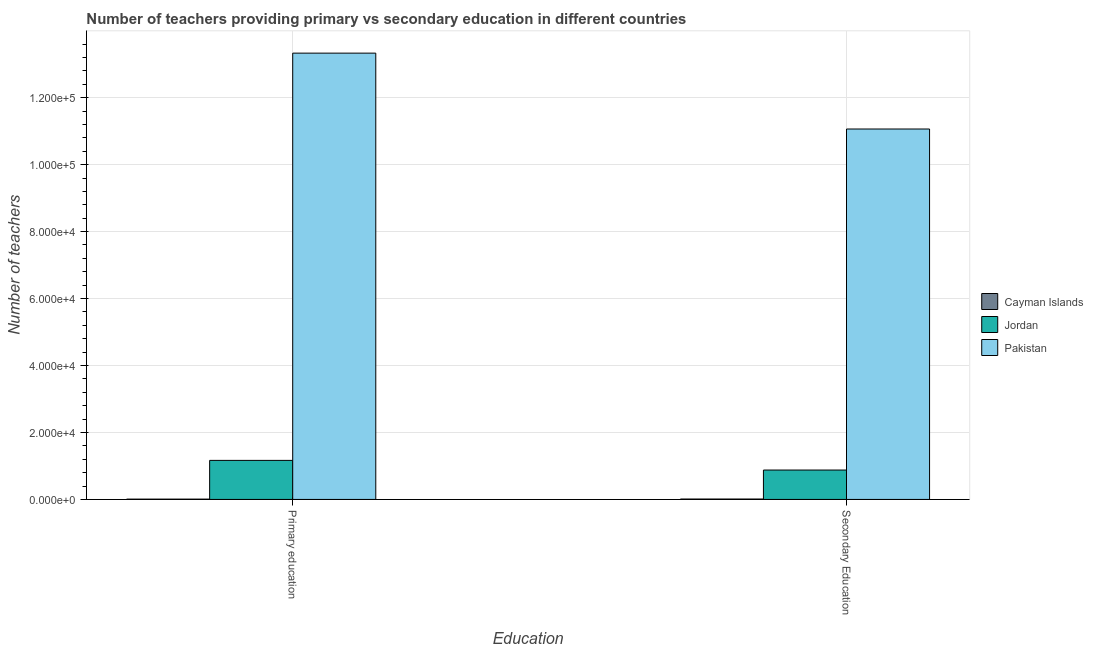How many groups of bars are there?
Your response must be concise. 2. Are the number of bars on each tick of the X-axis equal?
Give a very brief answer. Yes. How many bars are there on the 1st tick from the left?
Provide a short and direct response. 3. How many bars are there on the 1st tick from the right?
Your answer should be compact. 3. What is the number of secondary teachers in Jordan?
Keep it short and to the point. 8779. Across all countries, what is the maximum number of primary teachers?
Make the answer very short. 1.33e+05. Across all countries, what is the minimum number of secondary teachers?
Give a very brief answer. 114. In which country was the number of primary teachers minimum?
Your answer should be very brief. Cayman Islands. What is the total number of primary teachers in the graph?
Keep it short and to the point. 1.45e+05. What is the difference between the number of secondary teachers in Jordan and that in Pakistan?
Offer a very short reply. -1.02e+05. What is the difference between the number of primary teachers in Cayman Islands and the number of secondary teachers in Jordan?
Offer a terse response. -8691. What is the average number of secondary teachers per country?
Your answer should be very brief. 3.98e+04. What is the difference between the number of primary teachers and number of secondary teachers in Jordan?
Offer a very short reply. 2882. What is the ratio of the number of secondary teachers in Pakistan to that in Jordan?
Offer a terse response. 12.6. Is the number of primary teachers in Cayman Islands less than that in Pakistan?
Your answer should be compact. Yes. What does the 2nd bar from the left in Primary education represents?
Your answer should be compact. Jordan. How many bars are there?
Your answer should be compact. 6. Are all the bars in the graph horizontal?
Make the answer very short. No. How many countries are there in the graph?
Your answer should be compact. 3. Are the values on the major ticks of Y-axis written in scientific E-notation?
Give a very brief answer. Yes. Where does the legend appear in the graph?
Give a very brief answer. Center right. How many legend labels are there?
Make the answer very short. 3. What is the title of the graph?
Make the answer very short. Number of teachers providing primary vs secondary education in different countries. What is the label or title of the X-axis?
Keep it short and to the point. Education. What is the label or title of the Y-axis?
Your response must be concise. Number of teachers. What is the Number of teachers of Jordan in Primary education?
Provide a succinct answer. 1.17e+04. What is the Number of teachers in Pakistan in Primary education?
Give a very brief answer. 1.33e+05. What is the Number of teachers in Cayman Islands in Secondary Education?
Offer a terse response. 114. What is the Number of teachers in Jordan in Secondary Education?
Provide a succinct answer. 8779. What is the Number of teachers in Pakistan in Secondary Education?
Your response must be concise. 1.11e+05. Across all Education, what is the maximum Number of teachers in Cayman Islands?
Ensure brevity in your answer.  114. Across all Education, what is the maximum Number of teachers in Jordan?
Offer a terse response. 1.17e+04. Across all Education, what is the maximum Number of teachers in Pakistan?
Provide a succinct answer. 1.33e+05. Across all Education, what is the minimum Number of teachers of Jordan?
Provide a short and direct response. 8779. Across all Education, what is the minimum Number of teachers of Pakistan?
Keep it short and to the point. 1.11e+05. What is the total Number of teachers of Cayman Islands in the graph?
Your response must be concise. 202. What is the total Number of teachers of Jordan in the graph?
Provide a succinct answer. 2.04e+04. What is the total Number of teachers of Pakistan in the graph?
Your answer should be compact. 2.44e+05. What is the difference between the Number of teachers in Cayman Islands in Primary education and that in Secondary Education?
Keep it short and to the point. -26. What is the difference between the Number of teachers in Jordan in Primary education and that in Secondary Education?
Your response must be concise. 2882. What is the difference between the Number of teachers of Pakistan in Primary education and that in Secondary Education?
Your answer should be compact. 2.27e+04. What is the difference between the Number of teachers in Cayman Islands in Primary education and the Number of teachers in Jordan in Secondary Education?
Your answer should be compact. -8691. What is the difference between the Number of teachers in Cayman Islands in Primary education and the Number of teachers in Pakistan in Secondary Education?
Your answer should be compact. -1.11e+05. What is the difference between the Number of teachers in Jordan in Primary education and the Number of teachers in Pakistan in Secondary Education?
Your answer should be very brief. -9.90e+04. What is the average Number of teachers of Cayman Islands per Education?
Offer a very short reply. 101. What is the average Number of teachers in Jordan per Education?
Offer a very short reply. 1.02e+04. What is the average Number of teachers of Pakistan per Education?
Your answer should be compact. 1.22e+05. What is the difference between the Number of teachers in Cayman Islands and Number of teachers in Jordan in Primary education?
Provide a short and direct response. -1.16e+04. What is the difference between the Number of teachers in Cayman Islands and Number of teachers in Pakistan in Primary education?
Offer a terse response. -1.33e+05. What is the difference between the Number of teachers in Jordan and Number of teachers in Pakistan in Primary education?
Your answer should be very brief. -1.22e+05. What is the difference between the Number of teachers of Cayman Islands and Number of teachers of Jordan in Secondary Education?
Make the answer very short. -8665. What is the difference between the Number of teachers of Cayman Islands and Number of teachers of Pakistan in Secondary Education?
Your answer should be compact. -1.11e+05. What is the difference between the Number of teachers of Jordan and Number of teachers of Pakistan in Secondary Education?
Give a very brief answer. -1.02e+05. What is the ratio of the Number of teachers of Cayman Islands in Primary education to that in Secondary Education?
Offer a terse response. 0.77. What is the ratio of the Number of teachers in Jordan in Primary education to that in Secondary Education?
Your response must be concise. 1.33. What is the ratio of the Number of teachers in Pakistan in Primary education to that in Secondary Education?
Your answer should be compact. 1.2. What is the difference between the highest and the second highest Number of teachers in Cayman Islands?
Your answer should be very brief. 26. What is the difference between the highest and the second highest Number of teachers of Jordan?
Your response must be concise. 2882. What is the difference between the highest and the second highest Number of teachers of Pakistan?
Your answer should be compact. 2.27e+04. What is the difference between the highest and the lowest Number of teachers in Cayman Islands?
Your answer should be compact. 26. What is the difference between the highest and the lowest Number of teachers in Jordan?
Your answer should be very brief. 2882. What is the difference between the highest and the lowest Number of teachers of Pakistan?
Your answer should be very brief. 2.27e+04. 